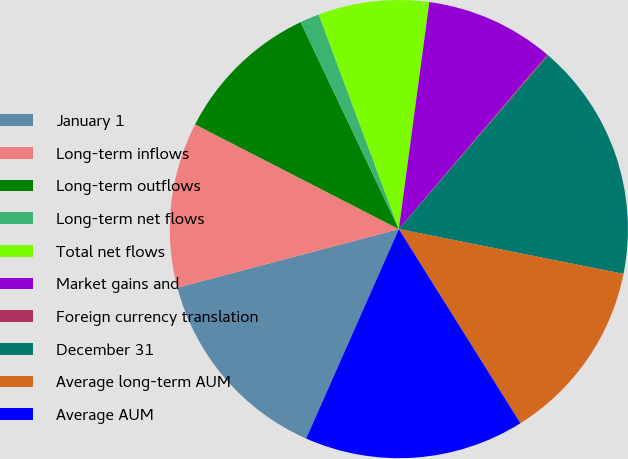Convert chart to OTSL. <chart><loc_0><loc_0><loc_500><loc_500><pie_chart><fcel>January 1<fcel>Long-term inflows<fcel>Long-term outflows<fcel>Long-term net flows<fcel>Total net flows<fcel>Market gains and<fcel>Foreign currency translation<fcel>December 31<fcel>Average long-term AUM<fcel>Average AUM<nl><fcel>14.25%<fcel>11.67%<fcel>10.39%<fcel>1.37%<fcel>7.81%<fcel>9.1%<fcel>0.08%<fcel>16.83%<fcel>12.96%<fcel>15.54%<nl></chart> 